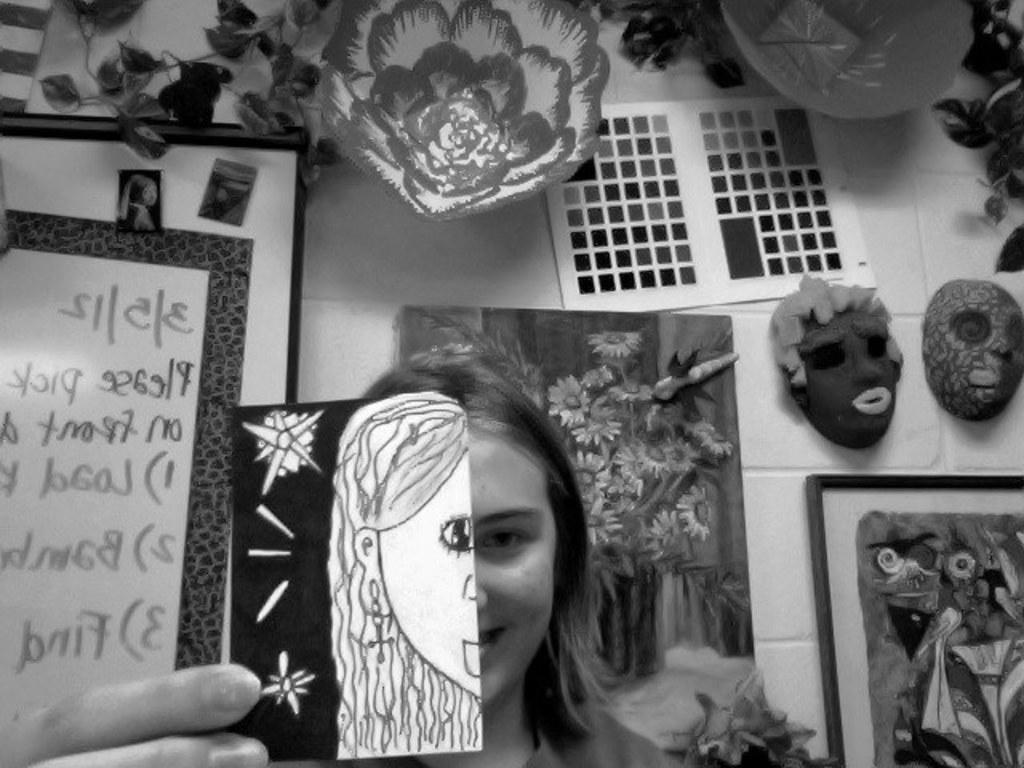Could you give a brief overview of what you see in this image? This is a black and white image and here we can see a lady holding a paper, with some sketch. In the background, there are boards and we can see some artificial leaves and some masks and an artificial flower on the wall. 